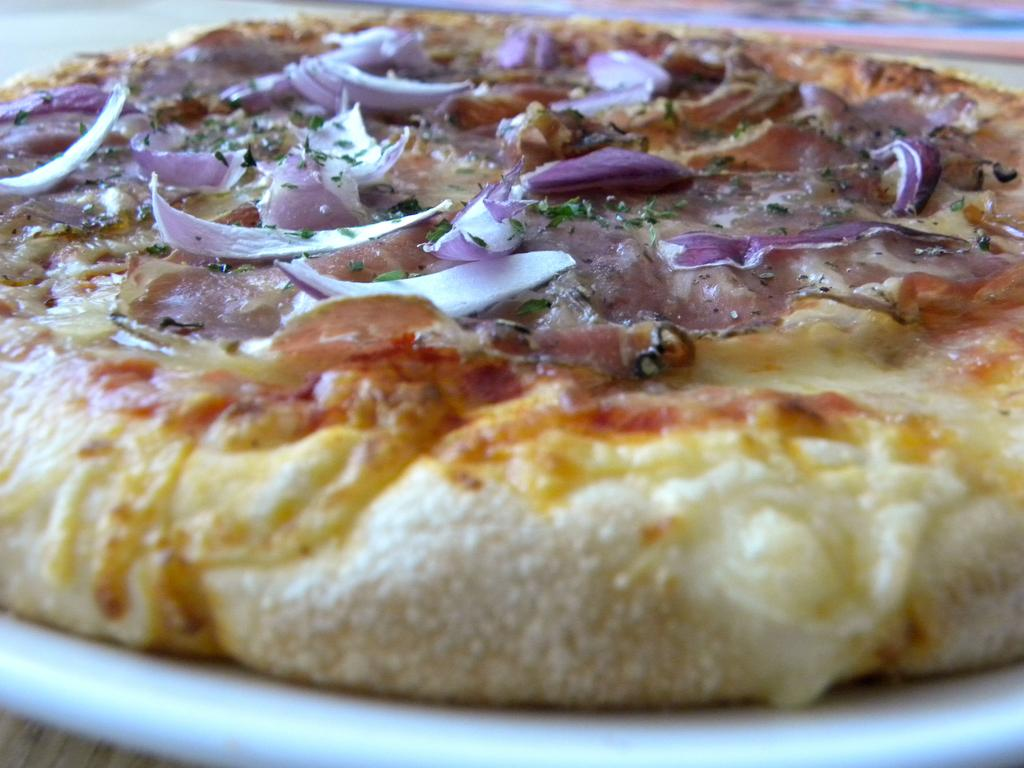What type of topping can be seen on the pizza in the image? There are onions on the pizza. Where is the pizza placed in the image? The pizza is on a plate. What type of brick is used to build the cemetery in the image? There is no brick or cemetery present in the image; it features a pizza with onions on a plate. 